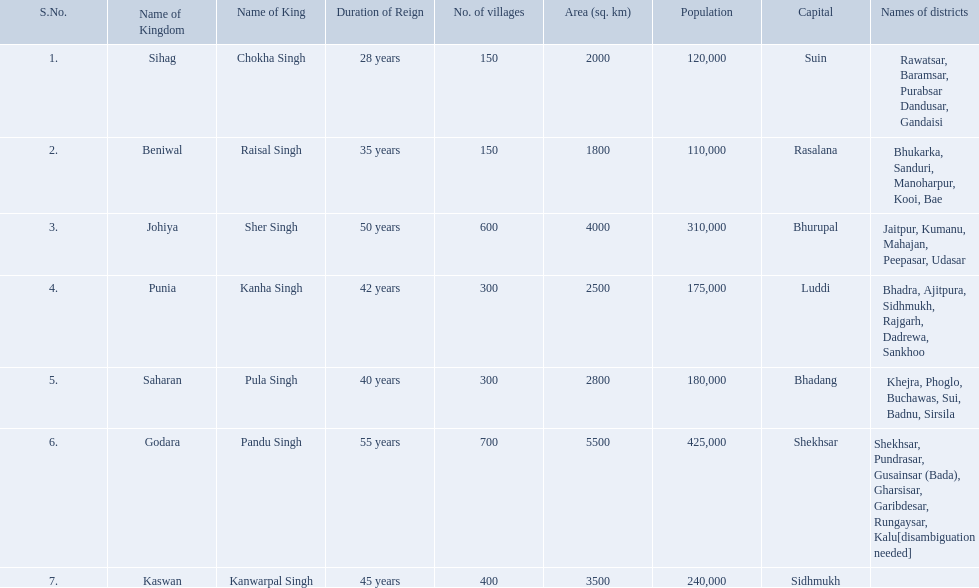What are all of the kingdoms? Sihag, Beniwal, Johiya, Punia, Saharan, Godara, Kaswan. How many villages do they contain? 150, 150, 600, 300, 300, 700, 400. How many are in godara? 700. Which kingdom comes next in highest amount of villages? Johiya. Which kingdom contained the least amount of villages along with sihag? Beniwal. Which kingdom contained the most villages? Godara. Which village was tied at second most villages with godara? Johiya. 